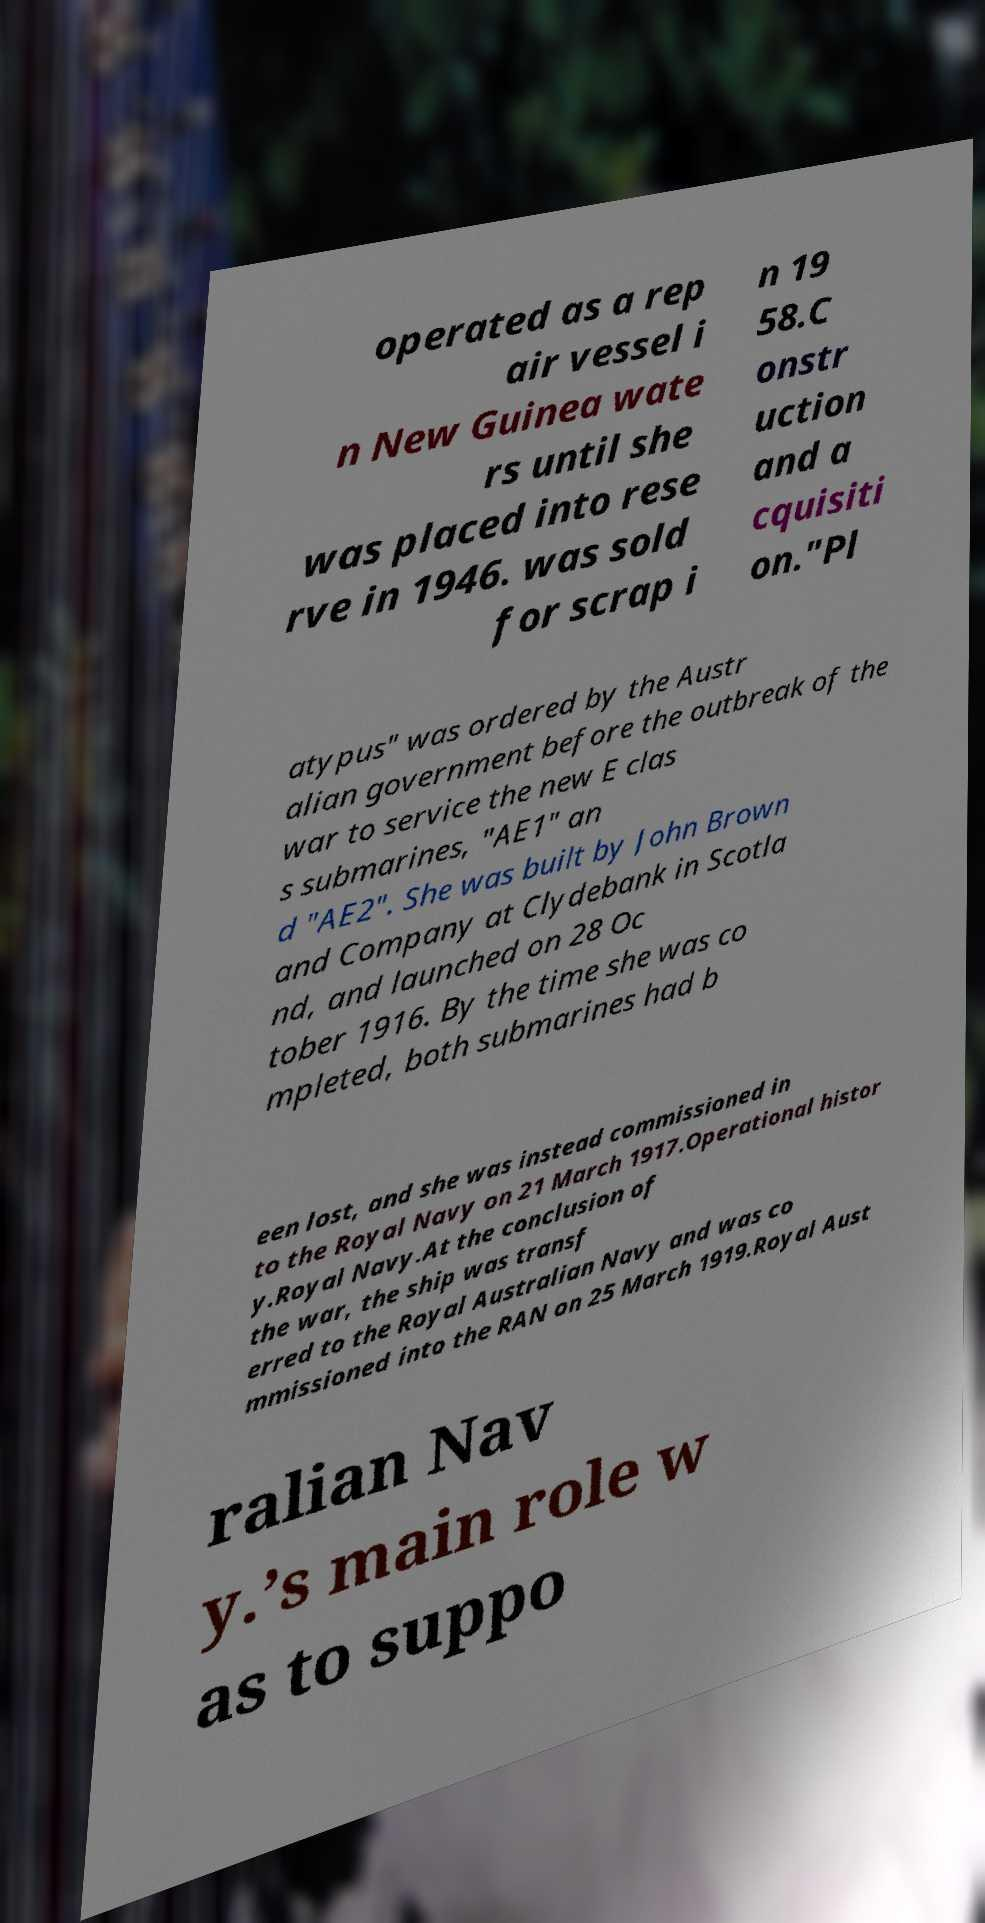Can you read and provide the text displayed in the image?This photo seems to have some interesting text. Can you extract and type it out for me? operated as a rep air vessel i n New Guinea wate rs until she was placed into rese rve in 1946. was sold for scrap i n 19 58.C onstr uction and a cquisiti on."Pl atypus" was ordered by the Austr alian government before the outbreak of the war to service the new E clas s submarines, "AE1" an d "AE2". She was built by John Brown and Company at Clydebank in Scotla nd, and launched on 28 Oc tober 1916. By the time she was co mpleted, both submarines had b een lost, and she was instead commissioned in to the Royal Navy on 21 March 1917.Operational histor y.Royal Navy.At the conclusion of the war, the ship was transf erred to the Royal Australian Navy and was co mmissioned into the RAN on 25 March 1919.Royal Aust ralian Nav y.’s main role w as to suppo 